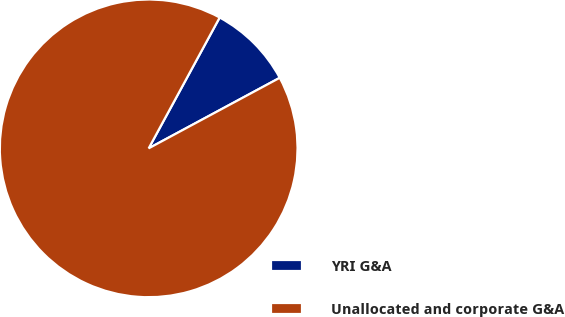Convert chart to OTSL. <chart><loc_0><loc_0><loc_500><loc_500><pie_chart><fcel>YRI G&A<fcel>Unallocated and corporate G&A<nl><fcel>9.23%<fcel>90.77%<nl></chart> 